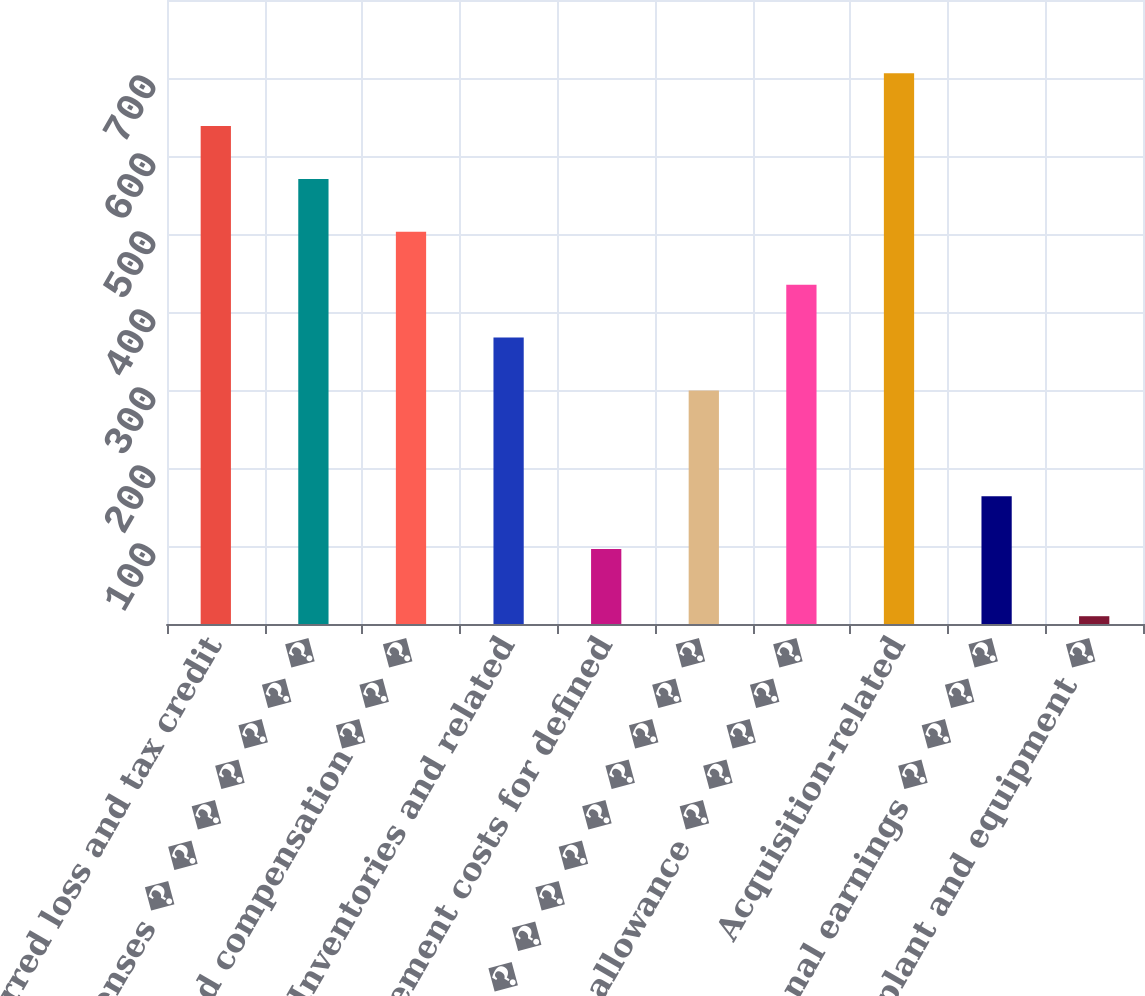<chart> <loc_0><loc_0><loc_500><loc_500><bar_chart><fcel>Deferred loss and tax credit<fcel>Accrued expenses � � � � � � �<fcel>Stock-based compensation� � �<fcel>Inventories and related<fcel>Retirement costs for defined<fcel>Other � � � � � � � � � � � �<fcel>Valuation allowance � � � � �<fcel>Acquisition-related<fcel>International earnings � � � �<fcel>Property plant and equipment �<nl><fcel>638.4<fcel>570.6<fcel>502.8<fcel>367.2<fcel>96<fcel>299.4<fcel>435<fcel>706.2<fcel>163.8<fcel>10<nl></chart> 